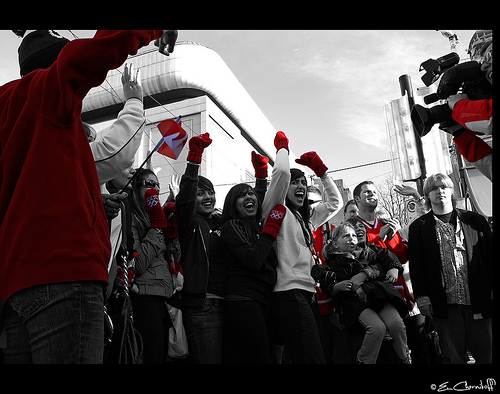<image>
Is there a glove on the girl? No. The glove is not positioned on the girl. They may be near each other, but the glove is not supported by or resting on top of the girl. 